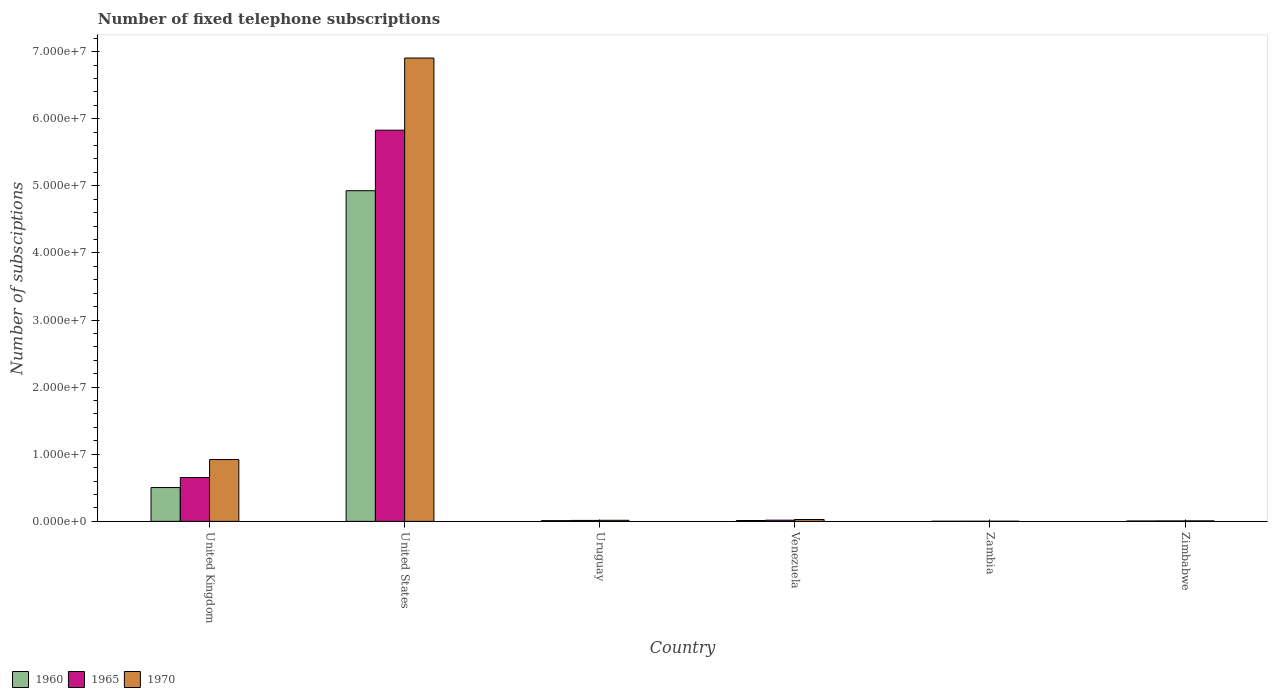How many groups of bars are there?
Offer a very short reply. 6. What is the label of the 4th group of bars from the left?
Your response must be concise. Venezuela. In how many cases, is the number of bars for a given country not equal to the number of legend labels?
Give a very brief answer. 0. What is the number of fixed telephone subscriptions in 1960 in Zambia?
Keep it short and to the point. 1.50e+04. Across all countries, what is the maximum number of fixed telephone subscriptions in 1960?
Offer a very short reply. 4.93e+07. Across all countries, what is the minimum number of fixed telephone subscriptions in 1965?
Provide a succinct answer. 1.71e+04. In which country was the number of fixed telephone subscriptions in 1970 maximum?
Provide a short and direct response. United States. In which country was the number of fixed telephone subscriptions in 1970 minimum?
Make the answer very short. Zambia. What is the total number of fixed telephone subscriptions in 1970 in the graph?
Offer a terse response. 7.88e+07. What is the difference between the number of fixed telephone subscriptions in 1970 in Zambia and that in Zimbabwe?
Offer a terse response. -5.18e+04. What is the difference between the number of fixed telephone subscriptions in 1970 in Venezuela and the number of fixed telephone subscriptions in 1965 in Zimbabwe?
Your answer should be very brief. 2.14e+05. What is the average number of fixed telephone subscriptions in 1970 per country?
Keep it short and to the point. 1.31e+07. What is the difference between the number of fixed telephone subscriptions of/in 1970 and number of fixed telephone subscriptions of/in 1960 in Zimbabwe?
Your answer should be very brief. 2.00e+04. In how many countries, is the number of fixed telephone subscriptions in 1965 greater than 8000000?
Give a very brief answer. 1. What is the ratio of the number of fixed telephone subscriptions in 1970 in Uruguay to that in Zambia?
Make the answer very short. 6.9. Is the number of fixed telephone subscriptions in 1965 in United Kingdom less than that in Venezuela?
Keep it short and to the point. No. What is the difference between the highest and the second highest number of fixed telephone subscriptions in 1965?
Your answer should be very brief. 5.81e+07. What is the difference between the highest and the lowest number of fixed telephone subscriptions in 1970?
Offer a very short reply. 6.90e+07. In how many countries, is the number of fixed telephone subscriptions in 1965 greater than the average number of fixed telephone subscriptions in 1965 taken over all countries?
Keep it short and to the point. 1. What does the 2nd bar from the right in Venezuela represents?
Offer a very short reply. 1965. How many bars are there?
Provide a succinct answer. 18. Are the values on the major ticks of Y-axis written in scientific E-notation?
Give a very brief answer. Yes. Does the graph contain any zero values?
Keep it short and to the point. No. Does the graph contain grids?
Provide a succinct answer. No. How many legend labels are there?
Your answer should be compact. 3. What is the title of the graph?
Offer a very short reply. Number of fixed telephone subscriptions. Does "1997" appear as one of the legend labels in the graph?
Your answer should be compact. No. What is the label or title of the Y-axis?
Ensure brevity in your answer.  Number of subsciptions. What is the Number of subsciptions in 1960 in United Kingdom?
Your answer should be compact. 5.04e+06. What is the Number of subsciptions of 1965 in United Kingdom?
Make the answer very short. 6.53e+06. What is the Number of subsciptions in 1970 in United Kingdom?
Give a very brief answer. 9.21e+06. What is the Number of subsciptions of 1960 in United States?
Provide a succinct answer. 4.93e+07. What is the Number of subsciptions of 1965 in United States?
Your response must be concise. 5.83e+07. What is the Number of subsciptions of 1970 in United States?
Make the answer very short. 6.90e+07. What is the Number of subsciptions of 1960 in Uruguay?
Keep it short and to the point. 1.10e+05. What is the Number of subsciptions in 1965 in Uruguay?
Your answer should be very brief. 1.42e+05. What is the Number of subsciptions in 1970 in Uruguay?
Offer a terse response. 1.60e+05. What is the Number of subsciptions in 1960 in Venezuela?
Your answer should be compact. 1.25e+05. What is the Number of subsciptions of 1965 in Venezuela?
Your answer should be compact. 1.78e+05. What is the Number of subsciptions in 1970 in Venezuela?
Ensure brevity in your answer.  2.79e+05. What is the Number of subsciptions in 1960 in Zambia?
Keep it short and to the point. 1.50e+04. What is the Number of subsciptions of 1965 in Zambia?
Your response must be concise. 1.71e+04. What is the Number of subsciptions in 1970 in Zambia?
Ensure brevity in your answer.  2.32e+04. What is the Number of subsciptions in 1960 in Zimbabwe?
Offer a very short reply. 5.50e+04. What is the Number of subsciptions of 1965 in Zimbabwe?
Give a very brief answer. 6.50e+04. What is the Number of subsciptions in 1970 in Zimbabwe?
Offer a terse response. 7.50e+04. Across all countries, what is the maximum Number of subsciptions of 1960?
Your response must be concise. 4.93e+07. Across all countries, what is the maximum Number of subsciptions in 1965?
Make the answer very short. 5.83e+07. Across all countries, what is the maximum Number of subsciptions of 1970?
Make the answer very short. 6.90e+07. Across all countries, what is the minimum Number of subsciptions in 1960?
Your answer should be very brief. 1.50e+04. Across all countries, what is the minimum Number of subsciptions in 1965?
Your answer should be very brief. 1.71e+04. Across all countries, what is the minimum Number of subsciptions of 1970?
Provide a short and direct response. 2.32e+04. What is the total Number of subsciptions in 1960 in the graph?
Your answer should be compact. 5.46e+07. What is the total Number of subsciptions in 1965 in the graph?
Make the answer very short. 6.52e+07. What is the total Number of subsciptions of 1970 in the graph?
Provide a succinct answer. 7.88e+07. What is the difference between the Number of subsciptions of 1960 in United Kingdom and that in United States?
Keep it short and to the point. -4.42e+07. What is the difference between the Number of subsciptions of 1965 in United Kingdom and that in United States?
Your response must be concise. -5.18e+07. What is the difference between the Number of subsciptions of 1970 in United Kingdom and that in United States?
Your answer should be compact. -5.98e+07. What is the difference between the Number of subsciptions of 1960 in United Kingdom and that in Uruguay?
Provide a succinct answer. 4.93e+06. What is the difference between the Number of subsciptions of 1965 in United Kingdom and that in Uruguay?
Keep it short and to the point. 6.39e+06. What is the difference between the Number of subsciptions of 1970 in United Kingdom and that in Uruguay?
Make the answer very short. 9.05e+06. What is the difference between the Number of subsciptions in 1960 in United Kingdom and that in Venezuela?
Give a very brief answer. 4.91e+06. What is the difference between the Number of subsciptions in 1965 in United Kingdom and that in Venezuela?
Offer a terse response. 6.36e+06. What is the difference between the Number of subsciptions of 1970 in United Kingdom and that in Venezuela?
Provide a succinct answer. 8.93e+06. What is the difference between the Number of subsciptions of 1960 in United Kingdom and that in Zambia?
Your answer should be very brief. 5.02e+06. What is the difference between the Number of subsciptions in 1965 in United Kingdom and that in Zambia?
Ensure brevity in your answer.  6.52e+06. What is the difference between the Number of subsciptions in 1970 in United Kingdom and that in Zambia?
Your answer should be compact. 9.19e+06. What is the difference between the Number of subsciptions of 1960 in United Kingdom and that in Zimbabwe?
Make the answer very short. 4.98e+06. What is the difference between the Number of subsciptions of 1965 in United Kingdom and that in Zimbabwe?
Provide a succinct answer. 6.47e+06. What is the difference between the Number of subsciptions of 1970 in United Kingdom and that in Zimbabwe?
Provide a short and direct response. 9.14e+06. What is the difference between the Number of subsciptions of 1960 in United States and that in Uruguay?
Your response must be concise. 4.92e+07. What is the difference between the Number of subsciptions of 1965 in United States and that in Uruguay?
Offer a very short reply. 5.81e+07. What is the difference between the Number of subsciptions of 1970 in United States and that in Uruguay?
Give a very brief answer. 6.89e+07. What is the difference between the Number of subsciptions in 1960 in United States and that in Venezuela?
Make the answer very short. 4.91e+07. What is the difference between the Number of subsciptions of 1965 in United States and that in Venezuela?
Your answer should be very brief. 5.81e+07. What is the difference between the Number of subsciptions in 1970 in United States and that in Venezuela?
Ensure brevity in your answer.  6.88e+07. What is the difference between the Number of subsciptions of 1960 in United States and that in Zambia?
Offer a very short reply. 4.93e+07. What is the difference between the Number of subsciptions in 1965 in United States and that in Zambia?
Offer a terse response. 5.83e+07. What is the difference between the Number of subsciptions of 1970 in United States and that in Zambia?
Provide a short and direct response. 6.90e+07. What is the difference between the Number of subsciptions of 1960 in United States and that in Zimbabwe?
Your response must be concise. 4.92e+07. What is the difference between the Number of subsciptions in 1965 in United States and that in Zimbabwe?
Your answer should be very brief. 5.82e+07. What is the difference between the Number of subsciptions of 1970 in United States and that in Zimbabwe?
Offer a terse response. 6.90e+07. What is the difference between the Number of subsciptions of 1960 in Uruguay and that in Venezuela?
Ensure brevity in your answer.  -1.50e+04. What is the difference between the Number of subsciptions of 1965 in Uruguay and that in Venezuela?
Make the answer very short. -3.60e+04. What is the difference between the Number of subsciptions of 1970 in Uruguay and that in Venezuela?
Offer a terse response. -1.19e+05. What is the difference between the Number of subsciptions of 1960 in Uruguay and that in Zambia?
Your response must be concise. 9.50e+04. What is the difference between the Number of subsciptions in 1965 in Uruguay and that in Zambia?
Your response must be concise. 1.25e+05. What is the difference between the Number of subsciptions of 1970 in Uruguay and that in Zambia?
Provide a short and direct response. 1.37e+05. What is the difference between the Number of subsciptions in 1960 in Uruguay and that in Zimbabwe?
Your answer should be very brief. 5.50e+04. What is the difference between the Number of subsciptions in 1965 in Uruguay and that in Zimbabwe?
Provide a short and direct response. 7.70e+04. What is the difference between the Number of subsciptions in 1970 in Uruguay and that in Zimbabwe?
Give a very brief answer. 8.50e+04. What is the difference between the Number of subsciptions of 1960 in Venezuela and that in Zambia?
Ensure brevity in your answer.  1.10e+05. What is the difference between the Number of subsciptions of 1965 in Venezuela and that in Zambia?
Keep it short and to the point. 1.61e+05. What is the difference between the Number of subsciptions in 1970 in Venezuela and that in Zambia?
Keep it short and to the point. 2.56e+05. What is the difference between the Number of subsciptions in 1965 in Venezuela and that in Zimbabwe?
Give a very brief answer. 1.13e+05. What is the difference between the Number of subsciptions in 1970 in Venezuela and that in Zimbabwe?
Your response must be concise. 2.04e+05. What is the difference between the Number of subsciptions in 1960 in Zambia and that in Zimbabwe?
Your answer should be very brief. -4.00e+04. What is the difference between the Number of subsciptions in 1965 in Zambia and that in Zimbabwe?
Keep it short and to the point. -4.79e+04. What is the difference between the Number of subsciptions of 1970 in Zambia and that in Zimbabwe?
Your answer should be very brief. -5.18e+04. What is the difference between the Number of subsciptions in 1960 in United Kingdom and the Number of subsciptions in 1965 in United States?
Your answer should be compact. -5.33e+07. What is the difference between the Number of subsciptions in 1960 in United Kingdom and the Number of subsciptions in 1970 in United States?
Ensure brevity in your answer.  -6.40e+07. What is the difference between the Number of subsciptions of 1965 in United Kingdom and the Number of subsciptions of 1970 in United States?
Ensure brevity in your answer.  -6.25e+07. What is the difference between the Number of subsciptions in 1960 in United Kingdom and the Number of subsciptions in 1965 in Uruguay?
Your response must be concise. 4.90e+06. What is the difference between the Number of subsciptions in 1960 in United Kingdom and the Number of subsciptions in 1970 in Uruguay?
Provide a succinct answer. 4.88e+06. What is the difference between the Number of subsciptions of 1965 in United Kingdom and the Number of subsciptions of 1970 in Uruguay?
Provide a succinct answer. 6.37e+06. What is the difference between the Number of subsciptions of 1960 in United Kingdom and the Number of subsciptions of 1965 in Venezuela?
Your answer should be compact. 4.86e+06. What is the difference between the Number of subsciptions in 1960 in United Kingdom and the Number of subsciptions in 1970 in Venezuela?
Provide a short and direct response. 4.76e+06. What is the difference between the Number of subsciptions in 1965 in United Kingdom and the Number of subsciptions in 1970 in Venezuela?
Ensure brevity in your answer.  6.26e+06. What is the difference between the Number of subsciptions of 1960 in United Kingdom and the Number of subsciptions of 1965 in Zambia?
Offer a terse response. 5.02e+06. What is the difference between the Number of subsciptions of 1960 in United Kingdom and the Number of subsciptions of 1970 in Zambia?
Make the answer very short. 5.01e+06. What is the difference between the Number of subsciptions in 1965 in United Kingdom and the Number of subsciptions in 1970 in Zambia?
Provide a succinct answer. 6.51e+06. What is the difference between the Number of subsciptions of 1960 in United Kingdom and the Number of subsciptions of 1965 in Zimbabwe?
Offer a very short reply. 4.97e+06. What is the difference between the Number of subsciptions of 1960 in United Kingdom and the Number of subsciptions of 1970 in Zimbabwe?
Keep it short and to the point. 4.96e+06. What is the difference between the Number of subsciptions of 1965 in United Kingdom and the Number of subsciptions of 1970 in Zimbabwe?
Keep it short and to the point. 6.46e+06. What is the difference between the Number of subsciptions of 1960 in United States and the Number of subsciptions of 1965 in Uruguay?
Make the answer very short. 4.91e+07. What is the difference between the Number of subsciptions of 1960 in United States and the Number of subsciptions of 1970 in Uruguay?
Make the answer very short. 4.91e+07. What is the difference between the Number of subsciptions of 1965 in United States and the Number of subsciptions of 1970 in Uruguay?
Your answer should be very brief. 5.81e+07. What is the difference between the Number of subsciptions of 1960 in United States and the Number of subsciptions of 1965 in Venezuela?
Your answer should be compact. 4.91e+07. What is the difference between the Number of subsciptions of 1960 in United States and the Number of subsciptions of 1970 in Venezuela?
Offer a terse response. 4.90e+07. What is the difference between the Number of subsciptions in 1965 in United States and the Number of subsciptions in 1970 in Venezuela?
Offer a terse response. 5.80e+07. What is the difference between the Number of subsciptions in 1960 in United States and the Number of subsciptions in 1965 in Zambia?
Your response must be concise. 4.93e+07. What is the difference between the Number of subsciptions in 1960 in United States and the Number of subsciptions in 1970 in Zambia?
Make the answer very short. 4.92e+07. What is the difference between the Number of subsciptions of 1965 in United States and the Number of subsciptions of 1970 in Zambia?
Ensure brevity in your answer.  5.83e+07. What is the difference between the Number of subsciptions in 1960 in United States and the Number of subsciptions in 1965 in Zimbabwe?
Give a very brief answer. 4.92e+07. What is the difference between the Number of subsciptions in 1960 in United States and the Number of subsciptions in 1970 in Zimbabwe?
Make the answer very short. 4.92e+07. What is the difference between the Number of subsciptions in 1965 in United States and the Number of subsciptions in 1970 in Zimbabwe?
Your response must be concise. 5.82e+07. What is the difference between the Number of subsciptions in 1960 in Uruguay and the Number of subsciptions in 1965 in Venezuela?
Your response must be concise. -6.80e+04. What is the difference between the Number of subsciptions of 1960 in Uruguay and the Number of subsciptions of 1970 in Venezuela?
Offer a terse response. -1.69e+05. What is the difference between the Number of subsciptions in 1965 in Uruguay and the Number of subsciptions in 1970 in Venezuela?
Your response must be concise. -1.37e+05. What is the difference between the Number of subsciptions in 1960 in Uruguay and the Number of subsciptions in 1965 in Zambia?
Your answer should be compact. 9.29e+04. What is the difference between the Number of subsciptions of 1960 in Uruguay and the Number of subsciptions of 1970 in Zambia?
Your response must be concise. 8.68e+04. What is the difference between the Number of subsciptions of 1965 in Uruguay and the Number of subsciptions of 1970 in Zambia?
Keep it short and to the point. 1.19e+05. What is the difference between the Number of subsciptions of 1960 in Uruguay and the Number of subsciptions of 1965 in Zimbabwe?
Your answer should be very brief. 4.50e+04. What is the difference between the Number of subsciptions of 1960 in Uruguay and the Number of subsciptions of 1970 in Zimbabwe?
Your response must be concise. 3.50e+04. What is the difference between the Number of subsciptions in 1965 in Uruguay and the Number of subsciptions in 1970 in Zimbabwe?
Keep it short and to the point. 6.70e+04. What is the difference between the Number of subsciptions of 1960 in Venezuela and the Number of subsciptions of 1965 in Zambia?
Provide a short and direct response. 1.08e+05. What is the difference between the Number of subsciptions in 1960 in Venezuela and the Number of subsciptions in 1970 in Zambia?
Make the answer very short. 1.02e+05. What is the difference between the Number of subsciptions in 1965 in Venezuela and the Number of subsciptions in 1970 in Zambia?
Provide a succinct answer. 1.55e+05. What is the difference between the Number of subsciptions of 1960 in Venezuela and the Number of subsciptions of 1965 in Zimbabwe?
Your answer should be very brief. 6.00e+04. What is the difference between the Number of subsciptions in 1960 in Venezuela and the Number of subsciptions in 1970 in Zimbabwe?
Your answer should be very brief. 5.00e+04. What is the difference between the Number of subsciptions of 1965 in Venezuela and the Number of subsciptions of 1970 in Zimbabwe?
Give a very brief answer. 1.03e+05. What is the difference between the Number of subsciptions of 1965 in Zambia and the Number of subsciptions of 1970 in Zimbabwe?
Offer a very short reply. -5.79e+04. What is the average Number of subsciptions in 1960 per country?
Offer a very short reply. 9.10e+06. What is the average Number of subsciptions in 1965 per country?
Offer a terse response. 1.09e+07. What is the average Number of subsciptions of 1970 per country?
Keep it short and to the point. 1.31e+07. What is the difference between the Number of subsciptions in 1960 and Number of subsciptions in 1965 in United Kingdom?
Your answer should be very brief. -1.50e+06. What is the difference between the Number of subsciptions in 1960 and Number of subsciptions in 1970 in United Kingdom?
Your answer should be very brief. -4.18e+06. What is the difference between the Number of subsciptions of 1965 and Number of subsciptions of 1970 in United Kingdom?
Ensure brevity in your answer.  -2.68e+06. What is the difference between the Number of subsciptions in 1960 and Number of subsciptions in 1965 in United States?
Provide a short and direct response. -9.02e+06. What is the difference between the Number of subsciptions of 1960 and Number of subsciptions of 1970 in United States?
Offer a terse response. -1.98e+07. What is the difference between the Number of subsciptions of 1965 and Number of subsciptions of 1970 in United States?
Provide a short and direct response. -1.08e+07. What is the difference between the Number of subsciptions in 1960 and Number of subsciptions in 1965 in Uruguay?
Your answer should be compact. -3.20e+04. What is the difference between the Number of subsciptions of 1960 and Number of subsciptions of 1970 in Uruguay?
Keep it short and to the point. -5.00e+04. What is the difference between the Number of subsciptions in 1965 and Number of subsciptions in 1970 in Uruguay?
Make the answer very short. -1.80e+04. What is the difference between the Number of subsciptions in 1960 and Number of subsciptions in 1965 in Venezuela?
Your response must be concise. -5.30e+04. What is the difference between the Number of subsciptions of 1960 and Number of subsciptions of 1970 in Venezuela?
Your answer should be very brief. -1.54e+05. What is the difference between the Number of subsciptions in 1965 and Number of subsciptions in 1970 in Venezuela?
Provide a succinct answer. -1.01e+05. What is the difference between the Number of subsciptions of 1960 and Number of subsciptions of 1965 in Zambia?
Your answer should be very brief. -2100. What is the difference between the Number of subsciptions of 1960 and Number of subsciptions of 1970 in Zambia?
Ensure brevity in your answer.  -8200. What is the difference between the Number of subsciptions in 1965 and Number of subsciptions in 1970 in Zambia?
Your answer should be very brief. -6100. What is the difference between the Number of subsciptions in 1960 and Number of subsciptions in 1970 in Zimbabwe?
Make the answer very short. -2.00e+04. What is the ratio of the Number of subsciptions in 1960 in United Kingdom to that in United States?
Keep it short and to the point. 0.1. What is the ratio of the Number of subsciptions of 1965 in United Kingdom to that in United States?
Your answer should be very brief. 0.11. What is the ratio of the Number of subsciptions of 1970 in United Kingdom to that in United States?
Your response must be concise. 0.13. What is the ratio of the Number of subsciptions of 1960 in United Kingdom to that in Uruguay?
Offer a terse response. 45.79. What is the ratio of the Number of subsciptions in 1965 in United Kingdom to that in Uruguay?
Offer a very short reply. 46.01. What is the ratio of the Number of subsciptions of 1970 in United Kingdom to that in Uruguay?
Your answer should be very brief. 57.58. What is the ratio of the Number of subsciptions in 1960 in United Kingdom to that in Venezuela?
Keep it short and to the point. 40.3. What is the ratio of the Number of subsciptions of 1965 in United Kingdom to that in Venezuela?
Your response must be concise. 36.71. What is the ratio of the Number of subsciptions of 1970 in United Kingdom to that in Venezuela?
Provide a succinct answer. 33.02. What is the ratio of the Number of subsciptions in 1960 in United Kingdom to that in Zambia?
Offer a very short reply. 335.8. What is the ratio of the Number of subsciptions of 1965 in United Kingdom to that in Zambia?
Ensure brevity in your answer.  382.11. What is the ratio of the Number of subsciptions of 1970 in United Kingdom to that in Zambia?
Give a very brief answer. 397.11. What is the ratio of the Number of subsciptions of 1960 in United Kingdom to that in Zimbabwe?
Your response must be concise. 91.58. What is the ratio of the Number of subsciptions in 1965 in United Kingdom to that in Zimbabwe?
Provide a succinct answer. 100.52. What is the ratio of the Number of subsciptions in 1970 in United Kingdom to that in Zimbabwe?
Your response must be concise. 122.84. What is the ratio of the Number of subsciptions in 1960 in United States to that in Uruguay?
Your answer should be compact. 447.9. What is the ratio of the Number of subsciptions of 1965 in United States to that in Uruguay?
Offer a very short reply. 410.49. What is the ratio of the Number of subsciptions in 1970 in United States to that in Uruguay?
Ensure brevity in your answer.  431.49. What is the ratio of the Number of subsciptions in 1960 in United States to that in Venezuela?
Provide a succinct answer. 394.15. What is the ratio of the Number of subsciptions of 1965 in United States to that in Venezuela?
Provide a succinct answer. 327.47. What is the ratio of the Number of subsciptions in 1970 in United States to that in Venezuela?
Offer a terse response. 247.45. What is the ratio of the Number of subsciptions of 1960 in United States to that in Zambia?
Provide a short and direct response. 3284.6. What is the ratio of the Number of subsciptions of 1965 in United States to that in Zambia?
Keep it short and to the point. 3408.71. What is the ratio of the Number of subsciptions of 1970 in United States to that in Zambia?
Make the answer very short. 2975.82. What is the ratio of the Number of subsciptions of 1960 in United States to that in Zimbabwe?
Give a very brief answer. 895.8. What is the ratio of the Number of subsciptions in 1965 in United States to that in Zimbabwe?
Offer a terse response. 896.75. What is the ratio of the Number of subsciptions in 1970 in United States to that in Zimbabwe?
Offer a very short reply. 920.52. What is the ratio of the Number of subsciptions in 1960 in Uruguay to that in Venezuela?
Offer a very short reply. 0.88. What is the ratio of the Number of subsciptions in 1965 in Uruguay to that in Venezuela?
Your answer should be compact. 0.8. What is the ratio of the Number of subsciptions of 1970 in Uruguay to that in Venezuela?
Ensure brevity in your answer.  0.57. What is the ratio of the Number of subsciptions of 1960 in Uruguay to that in Zambia?
Offer a very short reply. 7.33. What is the ratio of the Number of subsciptions of 1965 in Uruguay to that in Zambia?
Offer a very short reply. 8.3. What is the ratio of the Number of subsciptions of 1970 in Uruguay to that in Zambia?
Provide a succinct answer. 6.9. What is the ratio of the Number of subsciptions in 1965 in Uruguay to that in Zimbabwe?
Your answer should be compact. 2.18. What is the ratio of the Number of subsciptions of 1970 in Uruguay to that in Zimbabwe?
Provide a short and direct response. 2.13. What is the ratio of the Number of subsciptions of 1960 in Venezuela to that in Zambia?
Offer a terse response. 8.33. What is the ratio of the Number of subsciptions of 1965 in Venezuela to that in Zambia?
Your answer should be very brief. 10.41. What is the ratio of the Number of subsciptions in 1970 in Venezuela to that in Zambia?
Your response must be concise. 12.03. What is the ratio of the Number of subsciptions of 1960 in Venezuela to that in Zimbabwe?
Ensure brevity in your answer.  2.27. What is the ratio of the Number of subsciptions of 1965 in Venezuela to that in Zimbabwe?
Your answer should be very brief. 2.74. What is the ratio of the Number of subsciptions in 1970 in Venezuela to that in Zimbabwe?
Provide a short and direct response. 3.72. What is the ratio of the Number of subsciptions in 1960 in Zambia to that in Zimbabwe?
Your answer should be very brief. 0.27. What is the ratio of the Number of subsciptions in 1965 in Zambia to that in Zimbabwe?
Ensure brevity in your answer.  0.26. What is the ratio of the Number of subsciptions of 1970 in Zambia to that in Zimbabwe?
Your answer should be compact. 0.31. What is the difference between the highest and the second highest Number of subsciptions of 1960?
Your answer should be compact. 4.42e+07. What is the difference between the highest and the second highest Number of subsciptions of 1965?
Make the answer very short. 5.18e+07. What is the difference between the highest and the second highest Number of subsciptions of 1970?
Make the answer very short. 5.98e+07. What is the difference between the highest and the lowest Number of subsciptions of 1960?
Keep it short and to the point. 4.93e+07. What is the difference between the highest and the lowest Number of subsciptions of 1965?
Offer a terse response. 5.83e+07. What is the difference between the highest and the lowest Number of subsciptions in 1970?
Keep it short and to the point. 6.90e+07. 